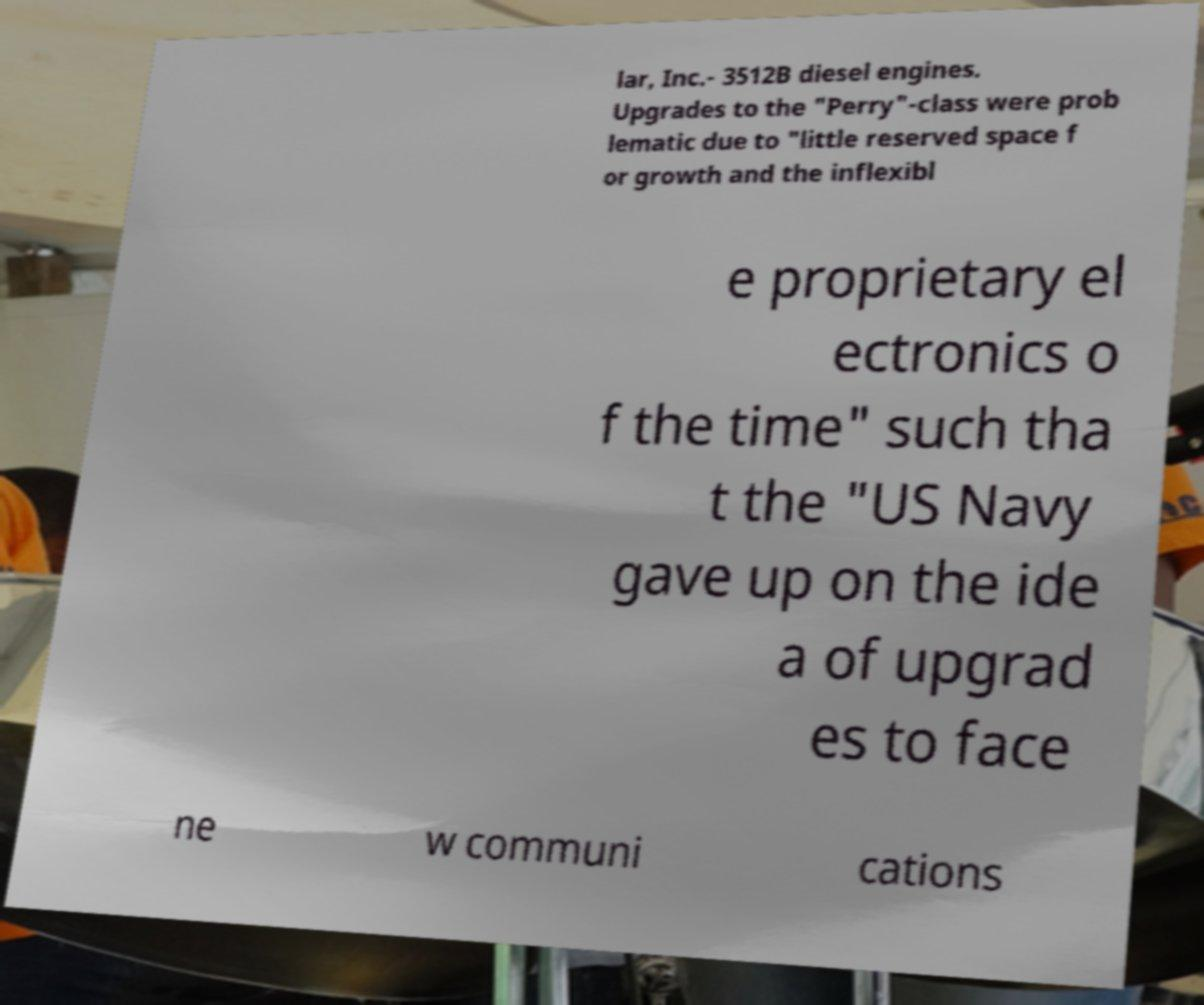Could you assist in decoding the text presented in this image and type it out clearly? lar, Inc.- 3512B diesel engines. Upgrades to the "Perry"-class were prob lematic due to "little reserved space f or growth and the inflexibl e proprietary el ectronics o f the time" such tha t the "US Navy gave up on the ide a of upgrad es to face ne w communi cations 